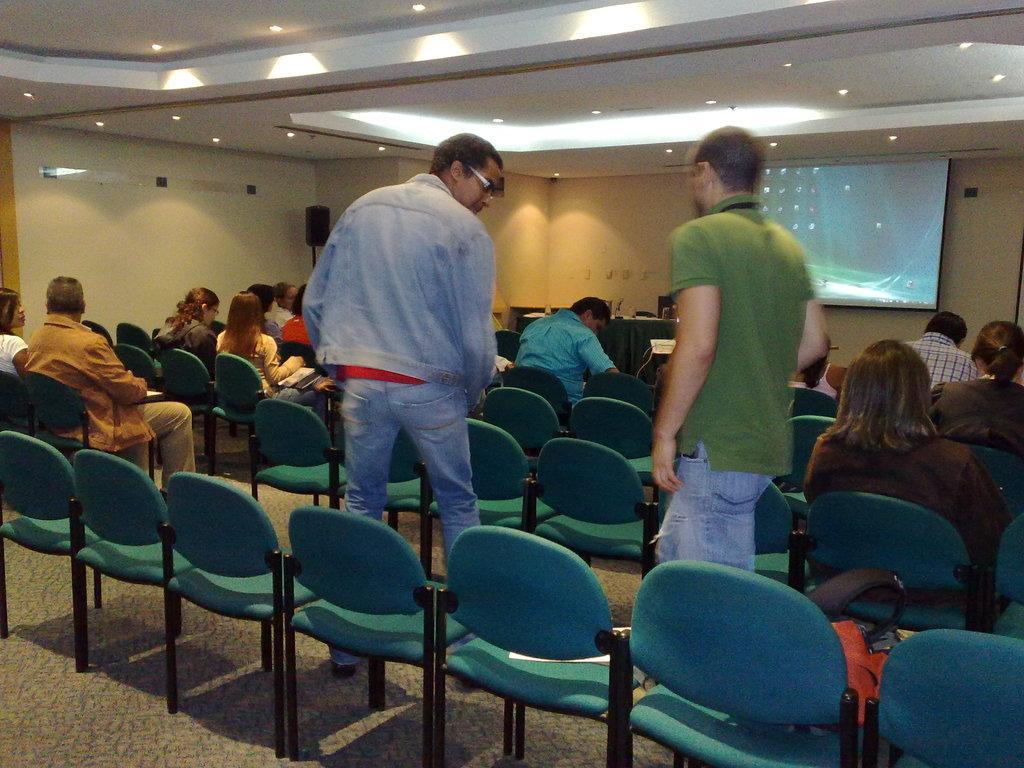Describe this image in one or two sentences. There are few people sitting on the chairs and two people are standing. These are the empty chairs which are green in color. This looks like a bag placed on the chair. This is a screen. These are the ceiling lights attached to the rooftop. I think this is the speaker which is black in color. Here I can see a table covered with a cloth with few objects on it. 